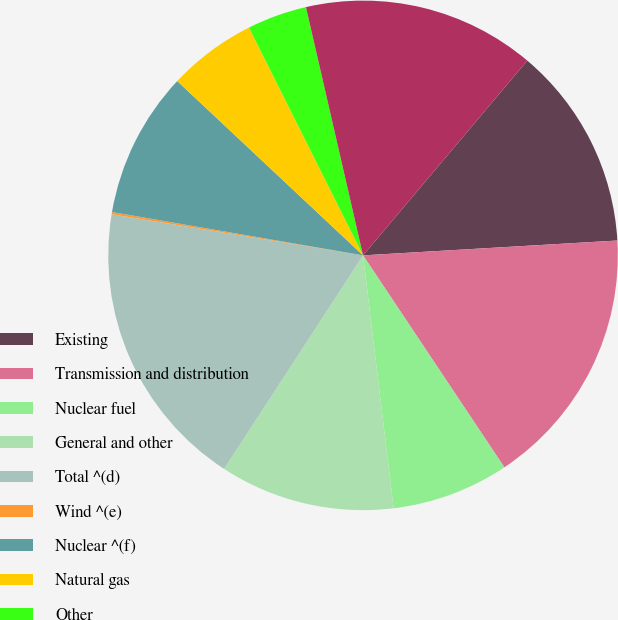Convert chart. <chart><loc_0><loc_0><loc_500><loc_500><pie_chart><fcel>Existing<fcel>Transmission and distribution<fcel>Nuclear fuel<fcel>General and other<fcel>Total ^(d)<fcel>Wind ^(e)<fcel>Nuclear ^(f)<fcel>Natural gas<fcel>Other<fcel>Total<nl><fcel>12.92%<fcel>16.57%<fcel>7.44%<fcel>11.1%<fcel>18.4%<fcel>0.14%<fcel>9.27%<fcel>5.62%<fcel>3.79%<fcel>14.75%<nl></chart> 